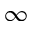<formula> <loc_0><loc_0><loc_500><loc_500>\infty</formula> 